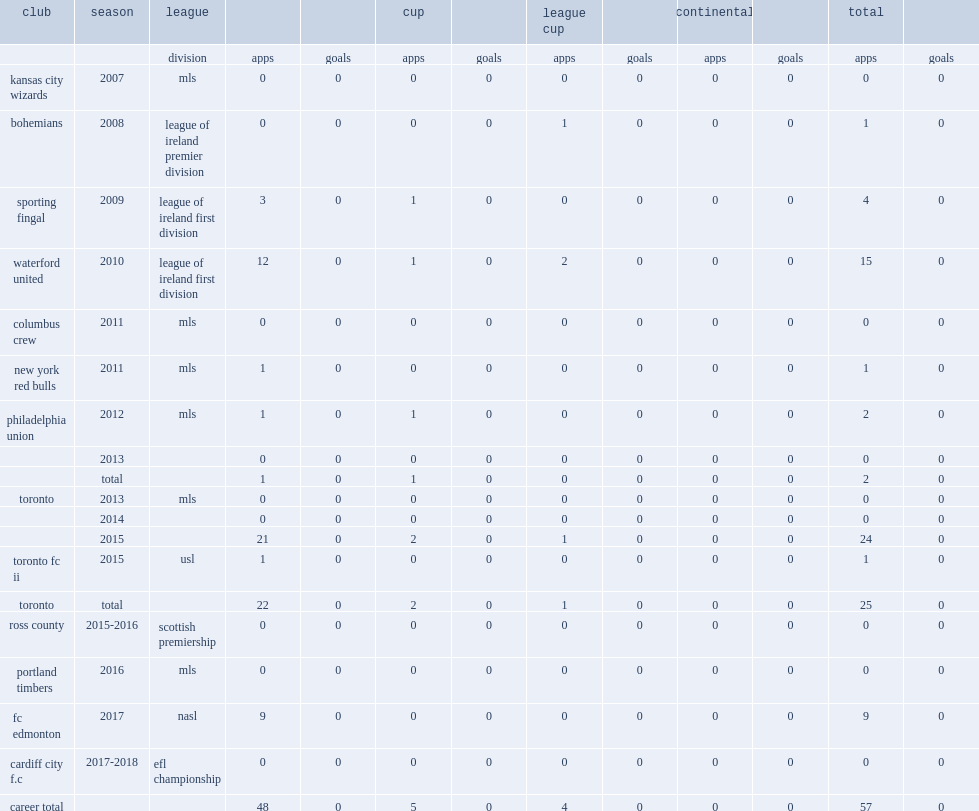Which club did konopka play for in 2009? Sporting fingal. 